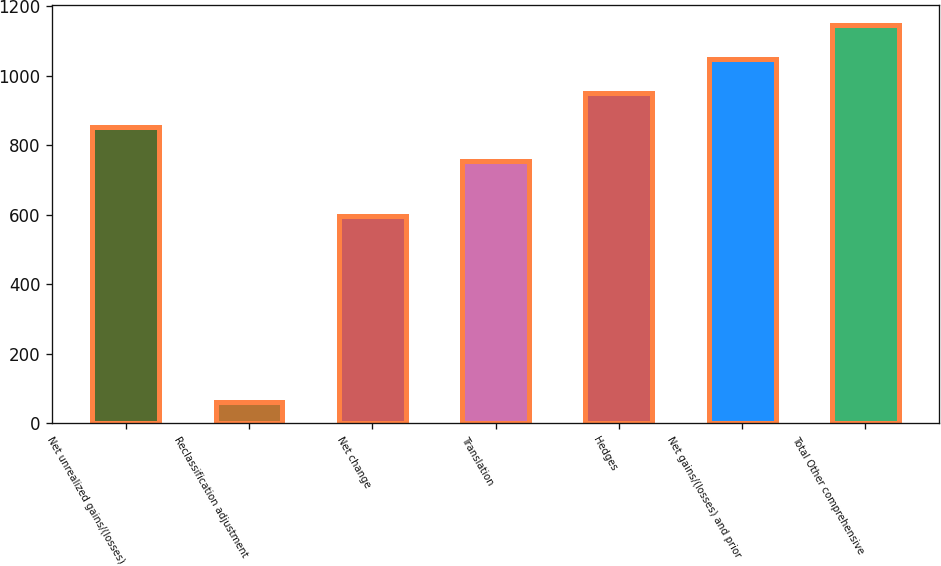Convert chart to OTSL. <chart><loc_0><loc_0><loc_500><loc_500><bar_chart><fcel>Net unrealized gains/(losses)<fcel>Reclassification adjustment<fcel>Net change<fcel>Translation<fcel>Hedges<fcel>Net gains/(losses) and prior<fcel>Total Other comprehensive<nl><fcel>852.3<fcel>59<fcel>595<fcel>754<fcel>950.6<fcel>1048.9<fcel>1147.2<nl></chart> 